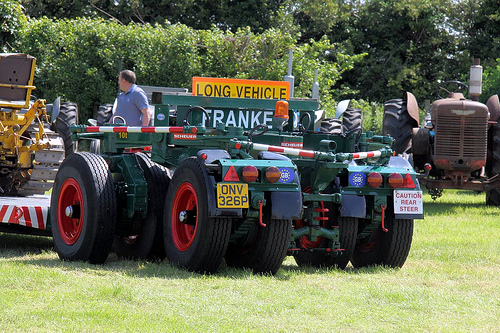<image>
Is there a man on the machine? No. The man is not positioned on the machine. They may be near each other, but the man is not supported by or resting on top of the machine. 